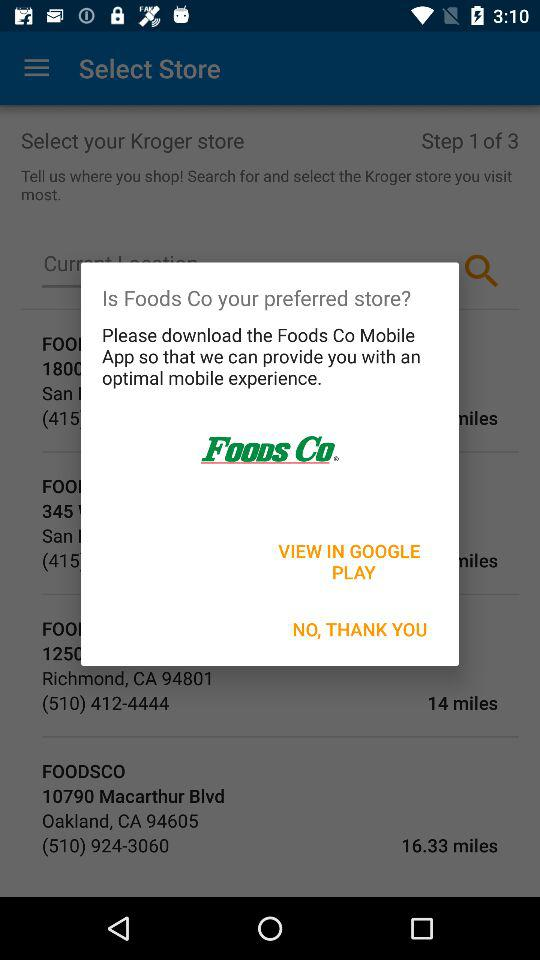How many steps in total are there? There are 3 steps in total. 